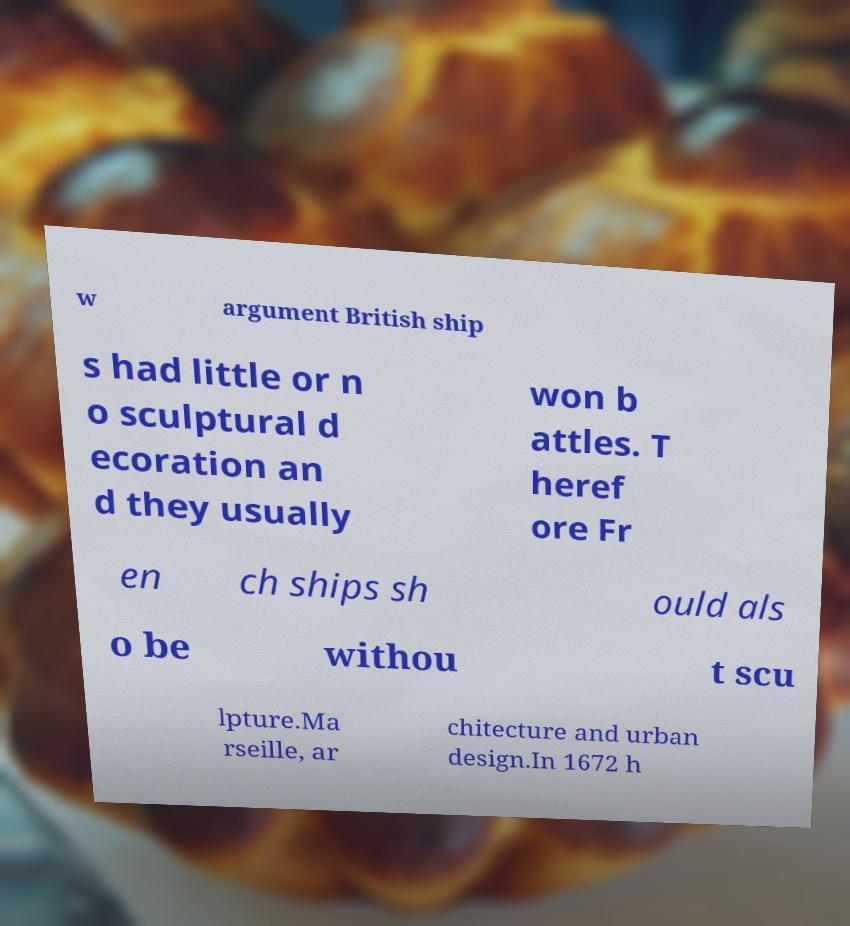There's text embedded in this image that I need extracted. Can you transcribe it verbatim? w argument British ship s had little or n o sculptural d ecoration an d they usually won b attles. T heref ore Fr en ch ships sh ould als o be withou t scu lpture.Ma rseille, ar chitecture and urban design.In 1672 h 